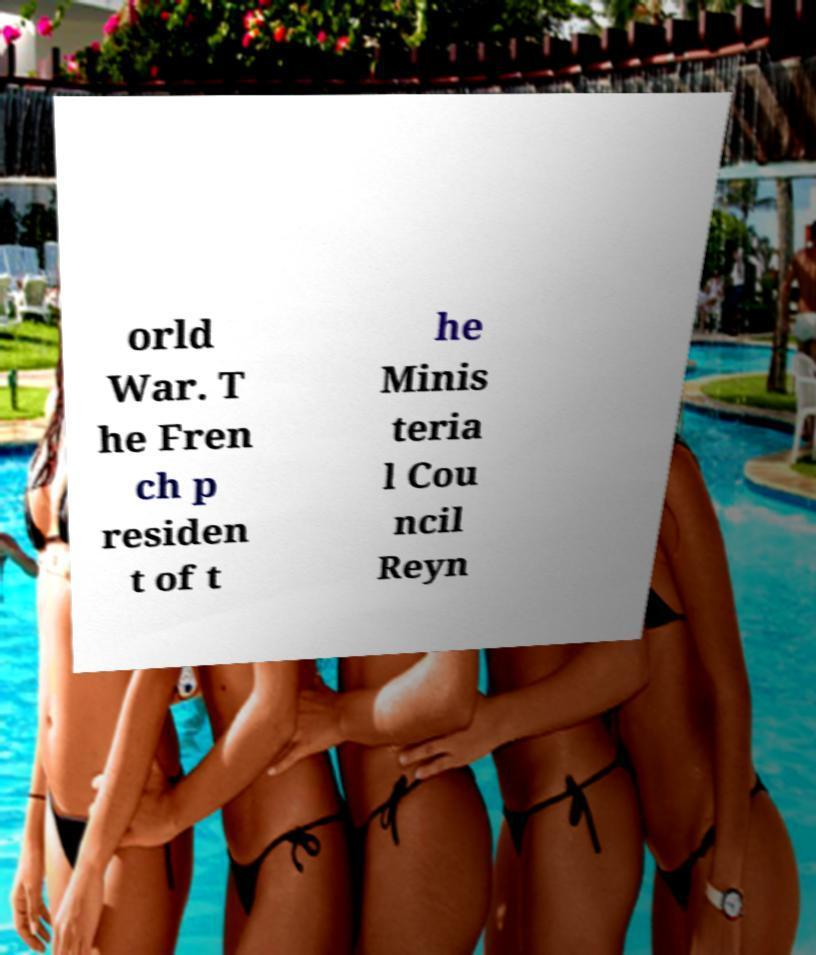Could you assist in decoding the text presented in this image and type it out clearly? orld War. T he Fren ch p residen t of t he Minis teria l Cou ncil Reyn 